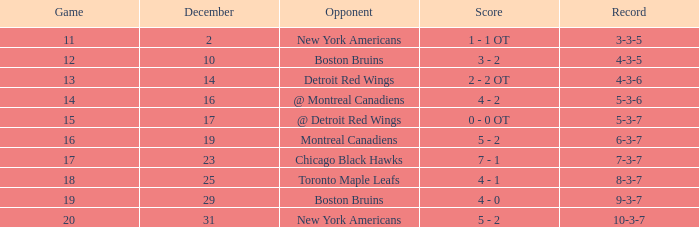Which score possesses a december less than 14, and a game of 12? 3 - 2. 